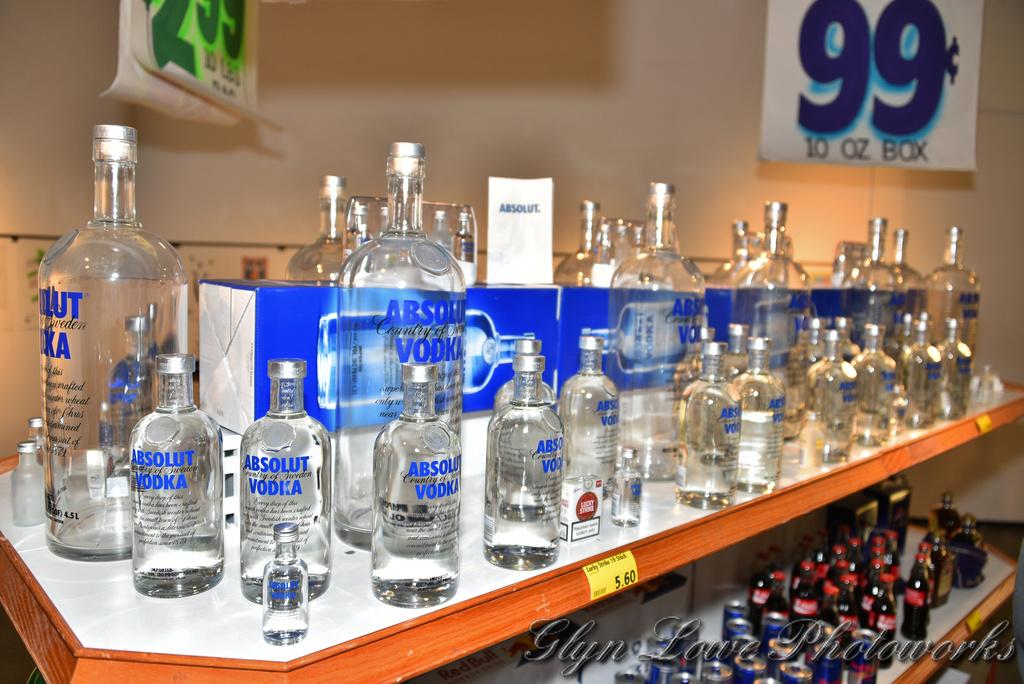What is 99 centers?
Provide a short and direct response. 10 oz box. 